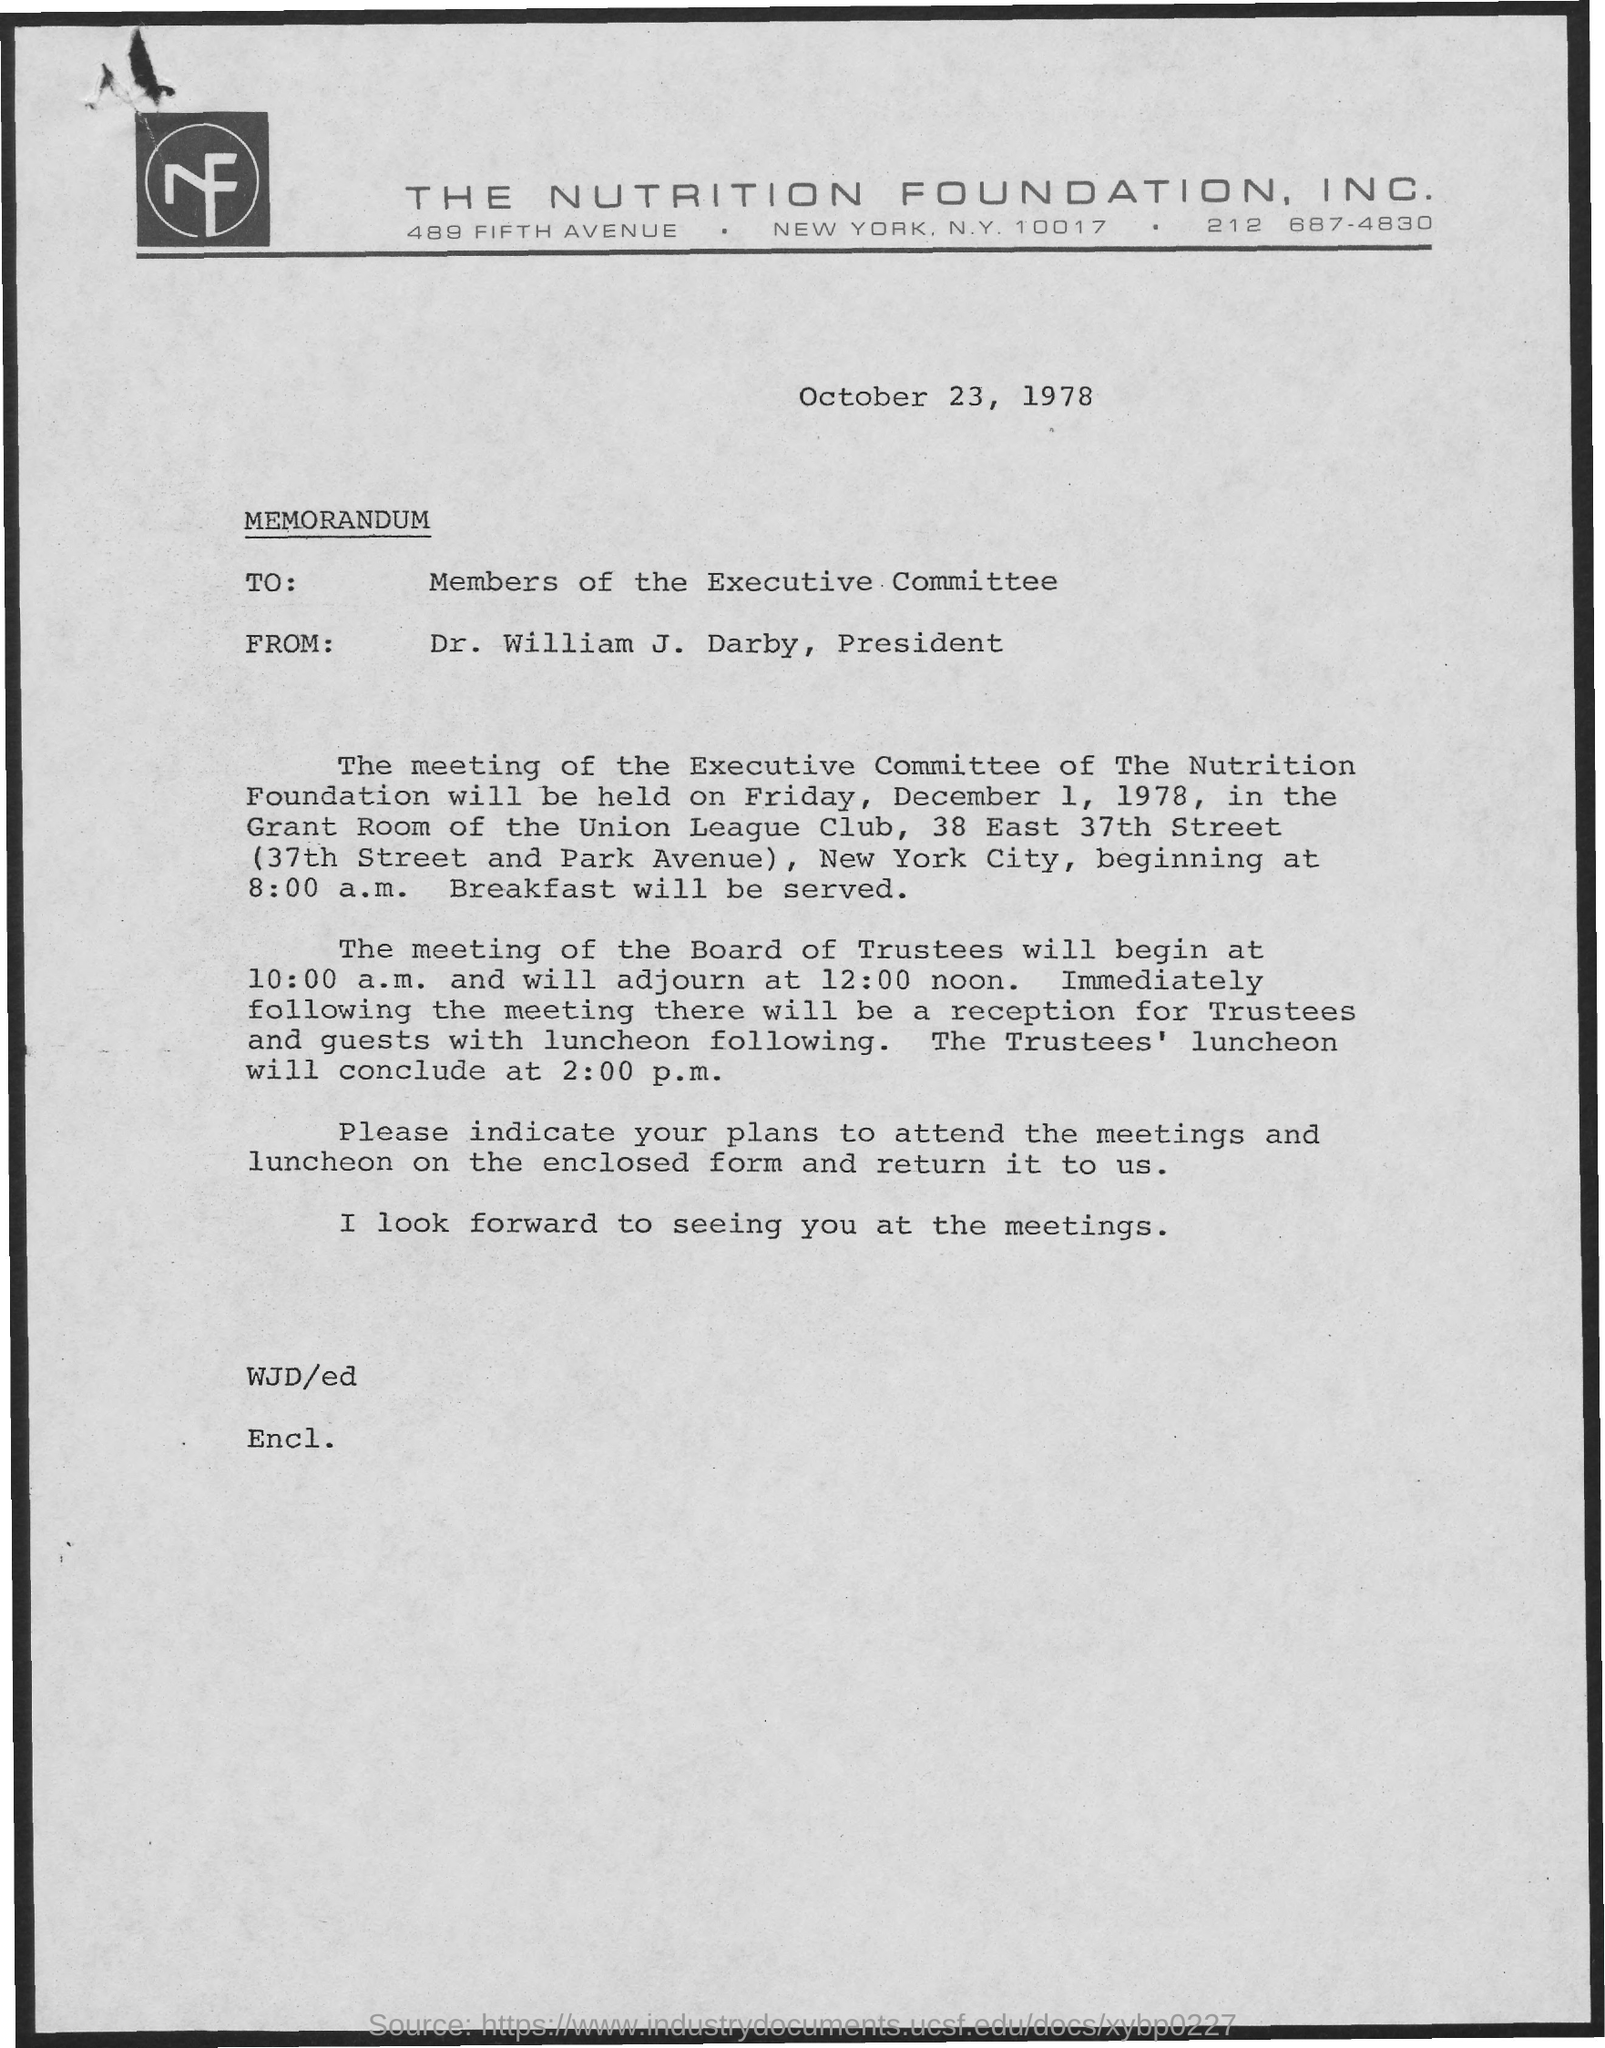What is the company name ?
Your answer should be compact. The Nutrition Foundation, Inc. Who is the Memorandum Addressed to ?
Offer a terse response. Members of the Executive Committee. Who is the memorandum from ?
Ensure brevity in your answer.  Dr. William J. Darby. When is the memorandum dated on ?
Provide a succinct answer. October 23, 1978. 